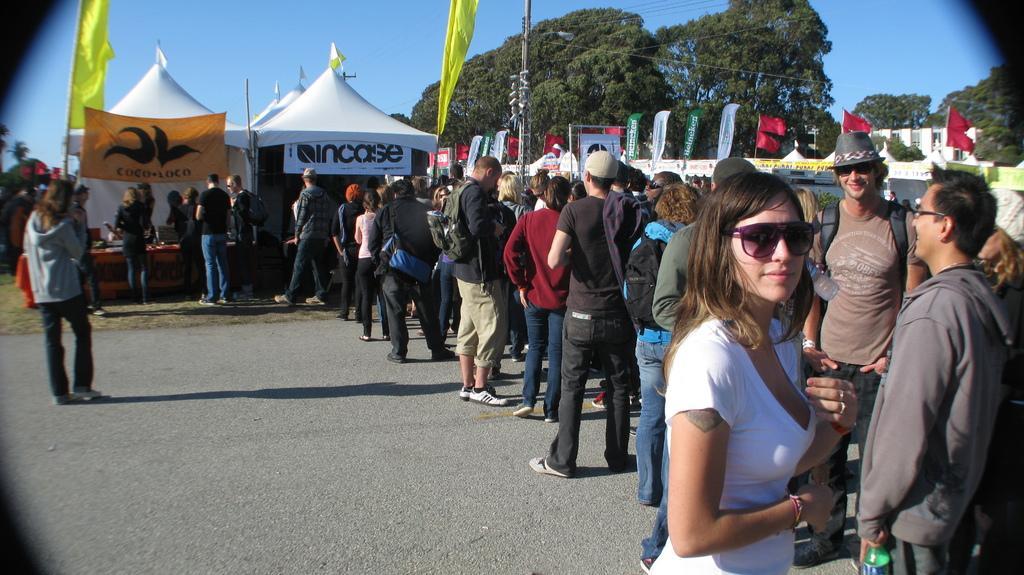How would you summarize this image in a sentence or two? In this image I can see number of persons are standing on the ground. In the background I can see few tents which are white in color, few flags which are yellow, blue, green and red in color and few banners. In the background I can see few trees and the sky. 